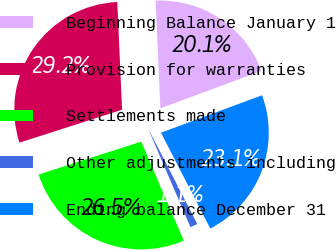Convert chart. <chart><loc_0><loc_0><loc_500><loc_500><pie_chart><fcel>Beginning Balance January 1<fcel>Provision for warranties<fcel>Settlements made<fcel>Other adjustments including<fcel>Ending balance December 31<nl><fcel>20.06%<fcel>29.24%<fcel>26.51%<fcel>1.11%<fcel>23.08%<nl></chart> 